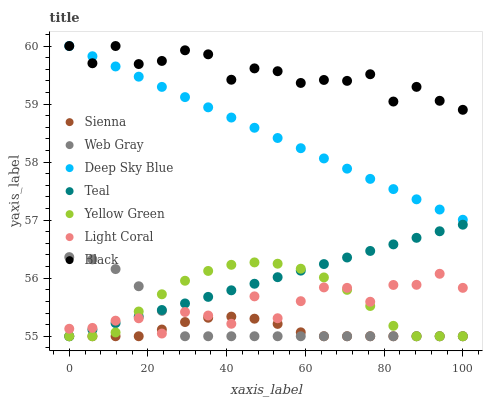Does Sienna have the minimum area under the curve?
Answer yes or no. Yes. Does Black have the maximum area under the curve?
Answer yes or no. Yes. Does Web Gray have the minimum area under the curve?
Answer yes or no. No. Does Web Gray have the maximum area under the curve?
Answer yes or no. No. Is Teal the smoothest?
Answer yes or no. Yes. Is Light Coral the roughest?
Answer yes or no. Yes. Is Web Gray the smoothest?
Answer yes or no. No. Is Web Gray the roughest?
Answer yes or no. No. Does Web Gray have the lowest value?
Answer yes or no. Yes. Does Deep Sky Blue have the lowest value?
Answer yes or no. No. Does Black have the highest value?
Answer yes or no. Yes. Does Web Gray have the highest value?
Answer yes or no. No. Is Web Gray less than Black?
Answer yes or no. Yes. Is Deep Sky Blue greater than Teal?
Answer yes or no. Yes. Does Light Coral intersect Teal?
Answer yes or no. Yes. Is Light Coral less than Teal?
Answer yes or no. No. Is Light Coral greater than Teal?
Answer yes or no. No. Does Web Gray intersect Black?
Answer yes or no. No. 